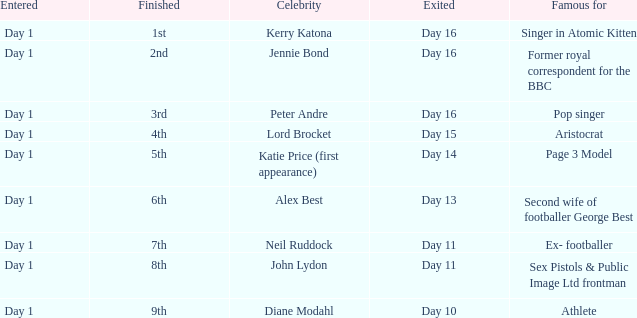Name the finished for exited of day 13 6th. 